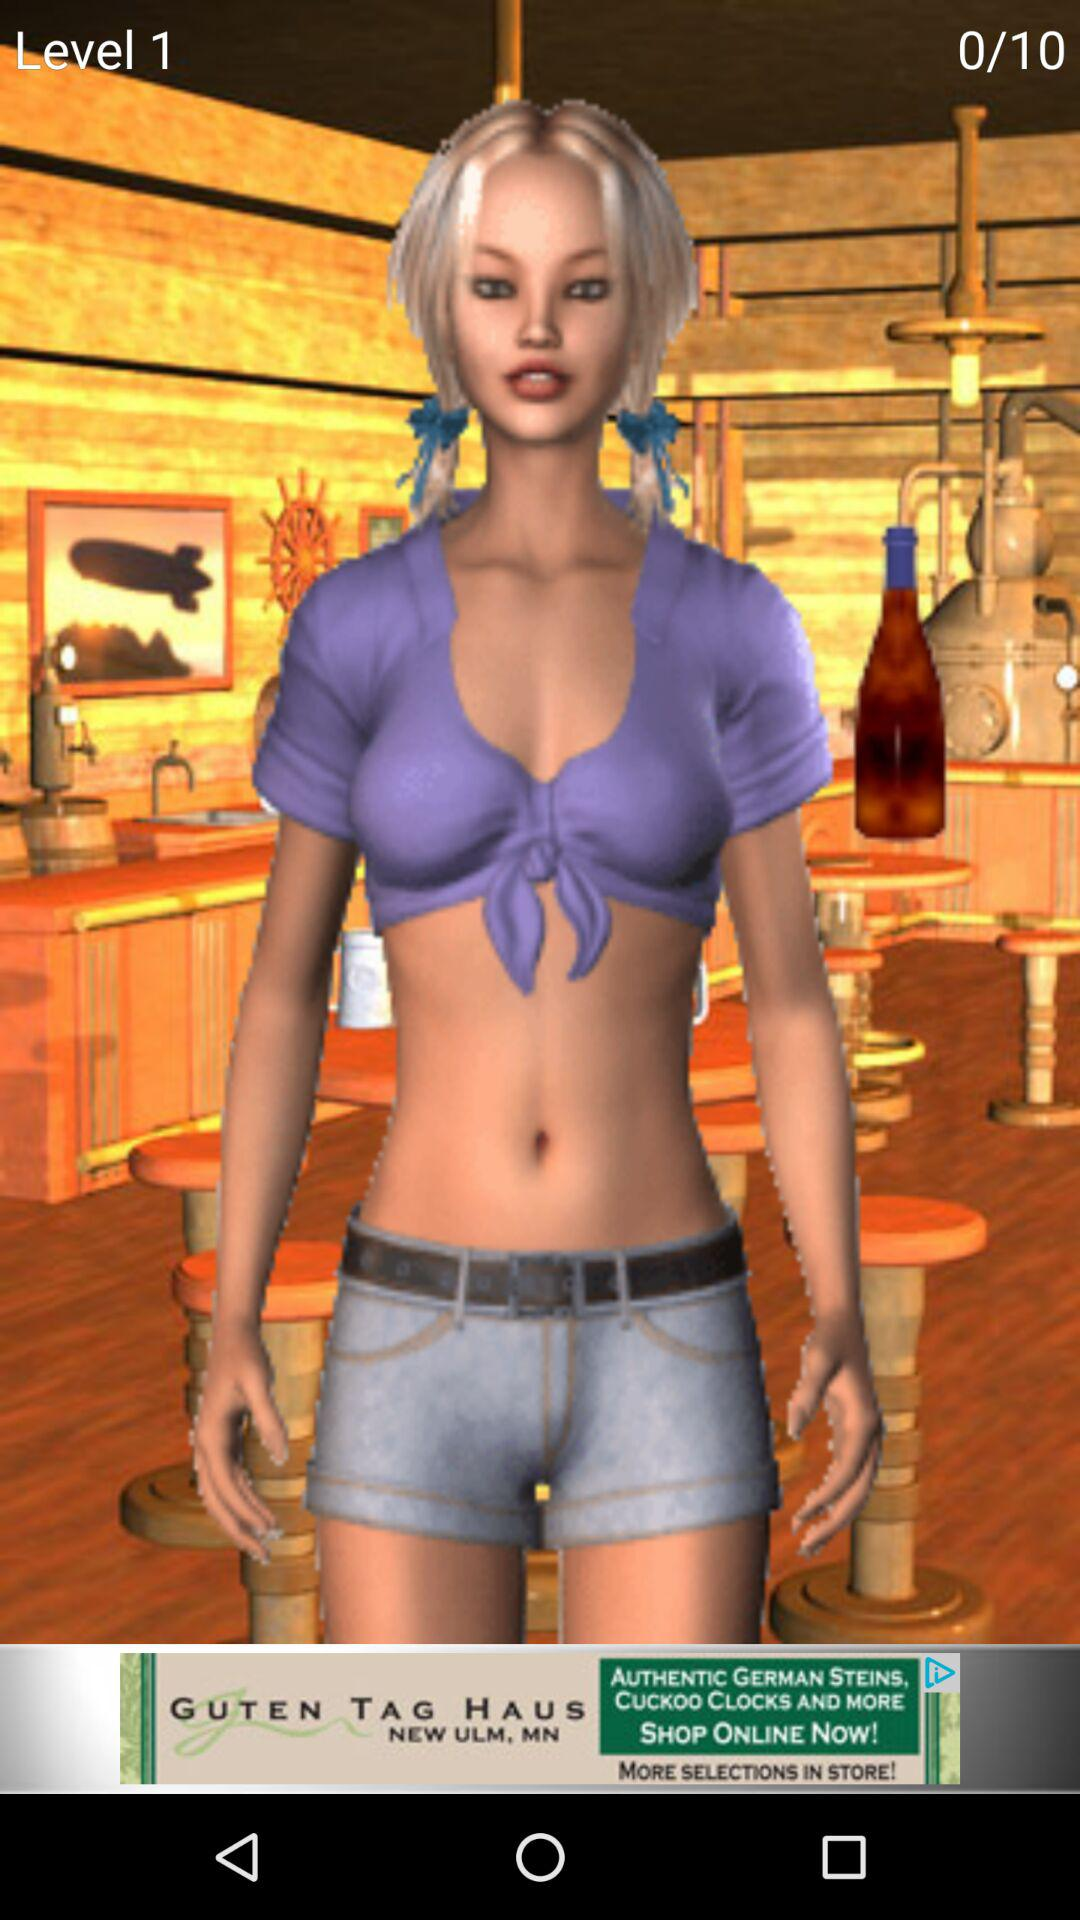At what level are we right now? Right now, you are at level 1. 